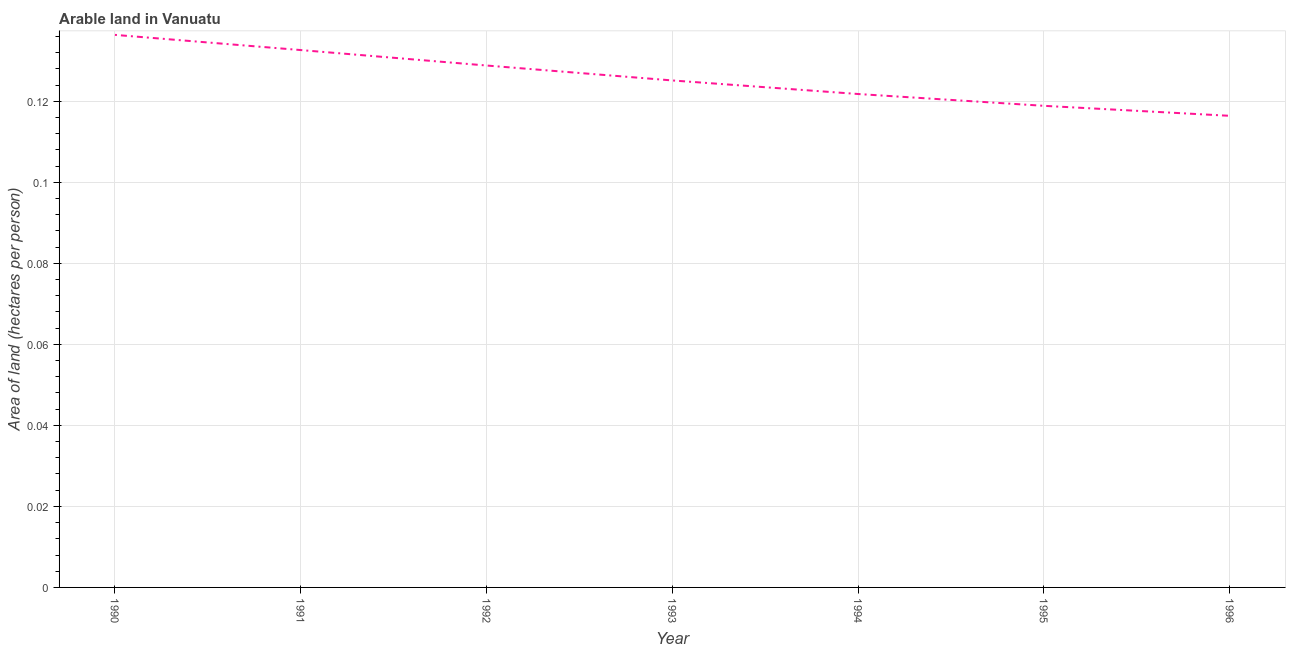What is the area of arable land in 1995?
Provide a succinct answer. 0.12. Across all years, what is the maximum area of arable land?
Provide a short and direct response. 0.14. Across all years, what is the minimum area of arable land?
Give a very brief answer. 0.12. In which year was the area of arable land minimum?
Give a very brief answer. 1996. What is the sum of the area of arable land?
Your answer should be very brief. 0.88. What is the difference between the area of arable land in 1991 and 1994?
Your answer should be compact. 0.01. What is the average area of arable land per year?
Your response must be concise. 0.13. What is the median area of arable land?
Your response must be concise. 0.13. In how many years, is the area of arable land greater than 0.008 hectares per person?
Offer a very short reply. 7. What is the ratio of the area of arable land in 1990 to that in 1995?
Provide a short and direct response. 1.15. What is the difference between the highest and the second highest area of arable land?
Your answer should be very brief. 0. What is the difference between the highest and the lowest area of arable land?
Provide a succinct answer. 0.02. How many lines are there?
Give a very brief answer. 1. Are the values on the major ticks of Y-axis written in scientific E-notation?
Your answer should be compact. No. Does the graph contain any zero values?
Offer a terse response. No. Does the graph contain grids?
Your answer should be very brief. Yes. What is the title of the graph?
Give a very brief answer. Arable land in Vanuatu. What is the label or title of the X-axis?
Your answer should be compact. Year. What is the label or title of the Y-axis?
Your response must be concise. Area of land (hectares per person). What is the Area of land (hectares per person) of 1990?
Your answer should be very brief. 0.14. What is the Area of land (hectares per person) in 1991?
Your answer should be compact. 0.13. What is the Area of land (hectares per person) of 1992?
Provide a short and direct response. 0.13. What is the Area of land (hectares per person) of 1993?
Your answer should be very brief. 0.13. What is the Area of land (hectares per person) of 1994?
Provide a succinct answer. 0.12. What is the Area of land (hectares per person) of 1995?
Make the answer very short. 0.12. What is the Area of land (hectares per person) in 1996?
Your answer should be very brief. 0.12. What is the difference between the Area of land (hectares per person) in 1990 and 1991?
Give a very brief answer. 0. What is the difference between the Area of land (hectares per person) in 1990 and 1992?
Give a very brief answer. 0.01. What is the difference between the Area of land (hectares per person) in 1990 and 1993?
Provide a succinct answer. 0.01. What is the difference between the Area of land (hectares per person) in 1990 and 1994?
Your response must be concise. 0.01. What is the difference between the Area of land (hectares per person) in 1990 and 1995?
Ensure brevity in your answer.  0.02. What is the difference between the Area of land (hectares per person) in 1990 and 1996?
Make the answer very short. 0.02. What is the difference between the Area of land (hectares per person) in 1991 and 1992?
Your answer should be very brief. 0. What is the difference between the Area of land (hectares per person) in 1991 and 1993?
Your answer should be compact. 0.01. What is the difference between the Area of land (hectares per person) in 1991 and 1994?
Your answer should be very brief. 0.01. What is the difference between the Area of land (hectares per person) in 1991 and 1995?
Provide a short and direct response. 0.01. What is the difference between the Area of land (hectares per person) in 1991 and 1996?
Ensure brevity in your answer.  0.02. What is the difference between the Area of land (hectares per person) in 1992 and 1993?
Keep it short and to the point. 0. What is the difference between the Area of land (hectares per person) in 1992 and 1994?
Offer a very short reply. 0.01. What is the difference between the Area of land (hectares per person) in 1992 and 1995?
Ensure brevity in your answer.  0.01. What is the difference between the Area of land (hectares per person) in 1992 and 1996?
Your response must be concise. 0.01. What is the difference between the Area of land (hectares per person) in 1993 and 1994?
Make the answer very short. 0. What is the difference between the Area of land (hectares per person) in 1993 and 1995?
Your answer should be very brief. 0.01. What is the difference between the Area of land (hectares per person) in 1993 and 1996?
Provide a succinct answer. 0.01. What is the difference between the Area of land (hectares per person) in 1994 and 1995?
Ensure brevity in your answer.  0. What is the difference between the Area of land (hectares per person) in 1994 and 1996?
Your answer should be very brief. 0.01. What is the difference between the Area of land (hectares per person) in 1995 and 1996?
Your answer should be compact. 0. What is the ratio of the Area of land (hectares per person) in 1990 to that in 1991?
Your answer should be very brief. 1.03. What is the ratio of the Area of land (hectares per person) in 1990 to that in 1992?
Offer a terse response. 1.06. What is the ratio of the Area of land (hectares per person) in 1990 to that in 1993?
Give a very brief answer. 1.09. What is the ratio of the Area of land (hectares per person) in 1990 to that in 1994?
Your answer should be compact. 1.12. What is the ratio of the Area of land (hectares per person) in 1990 to that in 1995?
Provide a short and direct response. 1.15. What is the ratio of the Area of land (hectares per person) in 1990 to that in 1996?
Give a very brief answer. 1.17. What is the ratio of the Area of land (hectares per person) in 1991 to that in 1993?
Keep it short and to the point. 1.06. What is the ratio of the Area of land (hectares per person) in 1991 to that in 1994?
Keep it short and to the point. 1.09. What is the ratio of the Area of land (hectares per person) in 1991 to that in 1995?
Give a very brief answer. 1.12. What is the ratio of the Area of land (hectares per person) in 1991 to that in 1996?
Ensure brevity in your answer.  1.14. What is the ratio of the Area of land (hectares per person) in 1992 to that in 1994?
Your answer should be very brief. 1.06. What is the ratio of the Area of land (hectares per person) in 1992 to that in 1995?
Your response must be concise. 1.08. What is the ratio of the Area of land (hectares per person) in 1992 to that in 1996?
Offer a very short reply. 1.11. What is the ratio of the Area of land (hectares per person) in 1993 to that in 1994?
Your response must be concise. 1.03. What is the ratio of the Area of land (hectares per person) in 1993 to that in 1995?
Keep it short and to the point. 1.05. What is the ratio of the Area of land (hectares per person) in 1993 to that in 1996?
Give a very brief answer. 1.07. What is the ratio of the Area of land (hectares per person) in 1994 to that in 1996?
Keep it short and to the point. 1.05. What is the ratio of the Area of land (hectares per person) in 1995 to that in 1996?
Offer a terse response. 1.02. 